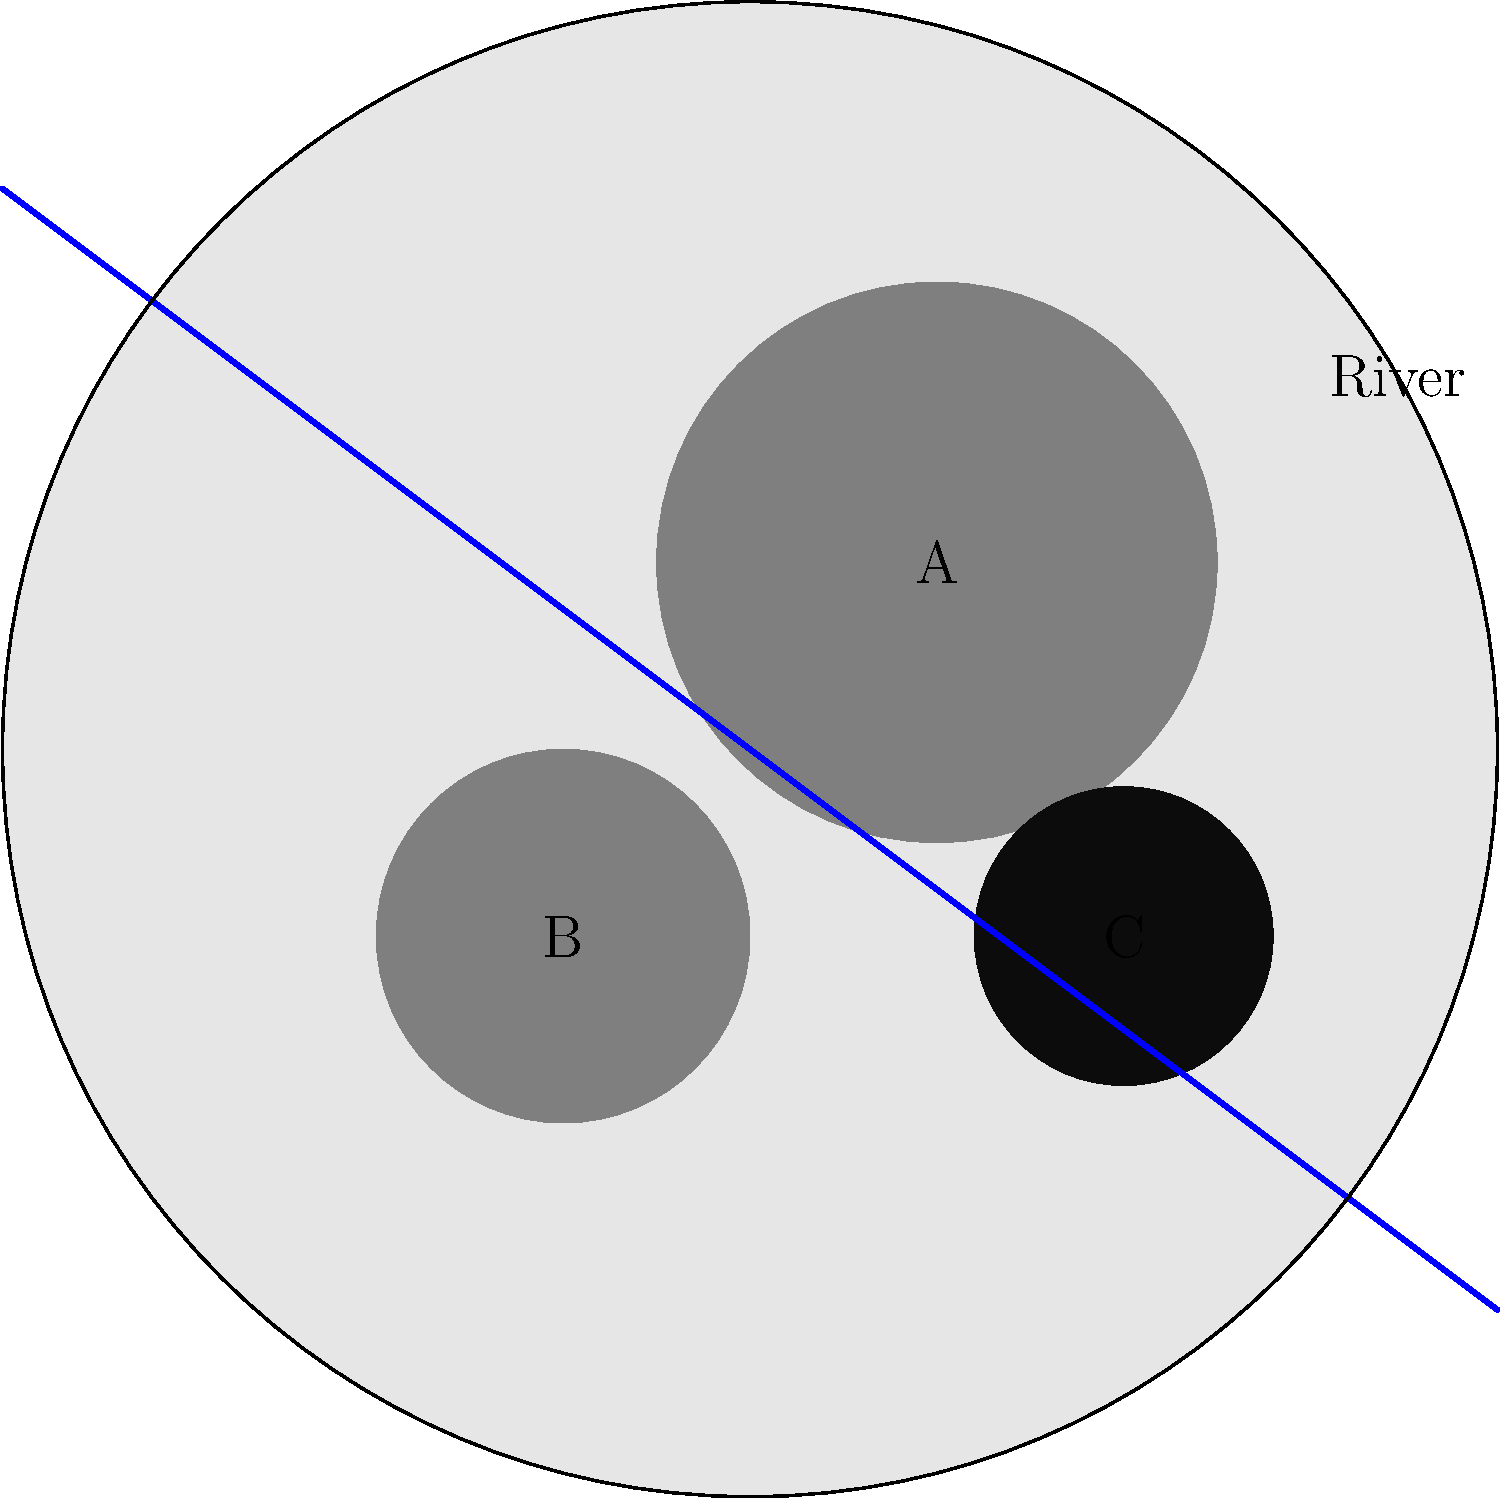Analyze the satellite image of a city and its surroundings. Areas A and B represent established urban zones, while C is a newly developed area. How might the expansion represented by area C impact local politics and resource allocation in this city? To answer this question, we need to consider several factors:

1. Location: Area C is situated on the outskirts of the city, near the river.

2. Size comparison: Area C is smaller than the established urban zones A and B, indicating a new but significant development.

3. Proximity to natural resources: Area C is close to the river, which could be a source of water or transportation.

4. Potential impact on local politics:
   a) Representation: The new development may demand political representation, potentially altering the balance of power in local government.
   b) Resource allocation: Area C may require new infrastructure (roads, utilities, public services), which could divert resources from established areas A and B.
   c) Environmental concerns: The proximity to the river might raise issues about water usage and environmental protection, influencing local political debates.
   d) Economic development: Area C might attract businesses or residents, potentially changing the city's economic dynamics and tax base.
   e) Urban planning: The expansion might prompt discussions about sustainable growth and urban sprawl in local political forums.

5. Demographic shifts: The new development could bring in a different socio-economic or cultural group, potentially changing voting patterns and political priorities.

Given these factors, the expansion represented by area C is likely to have a significant impact on local politics, primarily through demands for representation, resource allocation, and policy changes to address the needs and concerns of the new development.
Answer: Increased demand for representation and resources, potential shift in political priorities 